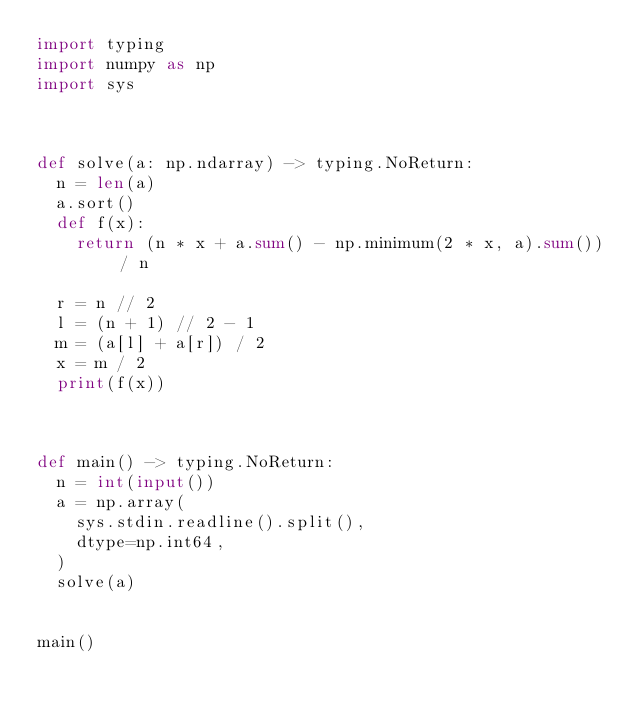<code> <loc_0><loc_0><loc_500><loc_500><_Python_>import typing 
import numpy as np 
import sys 



def solve(a: np.ndarray) -> typing.NoReturn:
  n = len(a)
  a.sort()
  def f(x):
    return (n * x + a.sum() - np.minimum(2 * x, a).sum()) / n

  r = n // 2
  l = (n + 1) // 2 - 1
  m = (a[l] + a[r]) / 2
  x = m / 2
  print(f(x))
  
  

def main() -> typing.NoReturn:
  n = int(input())
  a = np.array(
    sys.stdin.readline().split(),
    dtype=np.int64,
  )
  solve(a)


main()</code> 